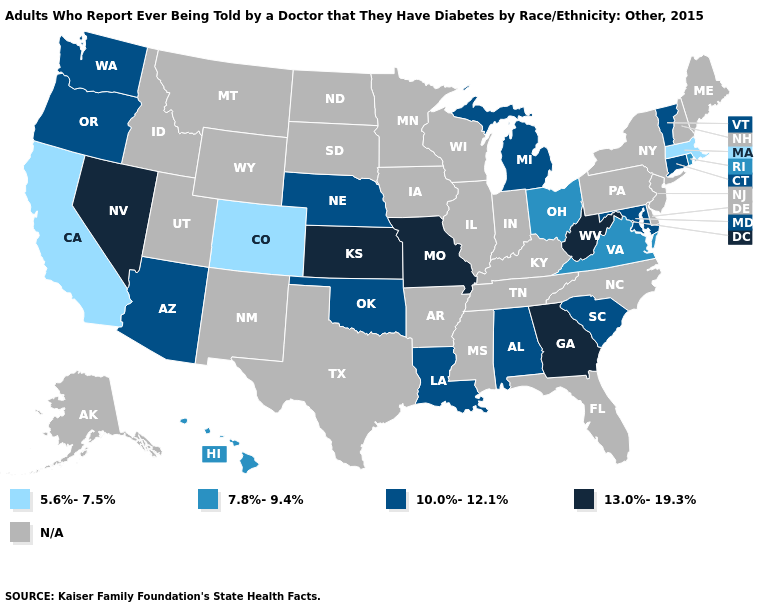What is the lowest value in the West?
Answer briefly. 5.6%-7.5%. Does Maryland have the highest value in the USA?
Concise answer only. No. Name the states that have a value in the range 7.8%-9.4%?
Quick response, please. Hawaii, Ohio, Rhode Island, Virginia. Does the first symbol in the legend represent the smallest category?
Write a very short answer. Yes. Among the states that border Michigan , which have the lowest value?
Short answer required. Ohio. Which states hav the highest value in the South?
Keep it brief. Georgia, West Virginia. Does Massachusetts have the lowest value in the USA?
Be succinct. Yes. What is the lowest value in the USA?
Answer briefly. 5.6%-7.5%. Is the legend a continuous bar?
Quick response, please. No. How many symbols are there in the legend?
Give a very brief answer. 5. What is the highest value in states that border New York?
Give a very brief answer. 10.0%-12.1%. What is the lowest value in states that border Georgia?
Quick response, please. 10.0%-12.1%. How many symbols are there in the legend?
Write a very short answer. 5. What is the value of Illinois?
Quick response, please. N/A. 